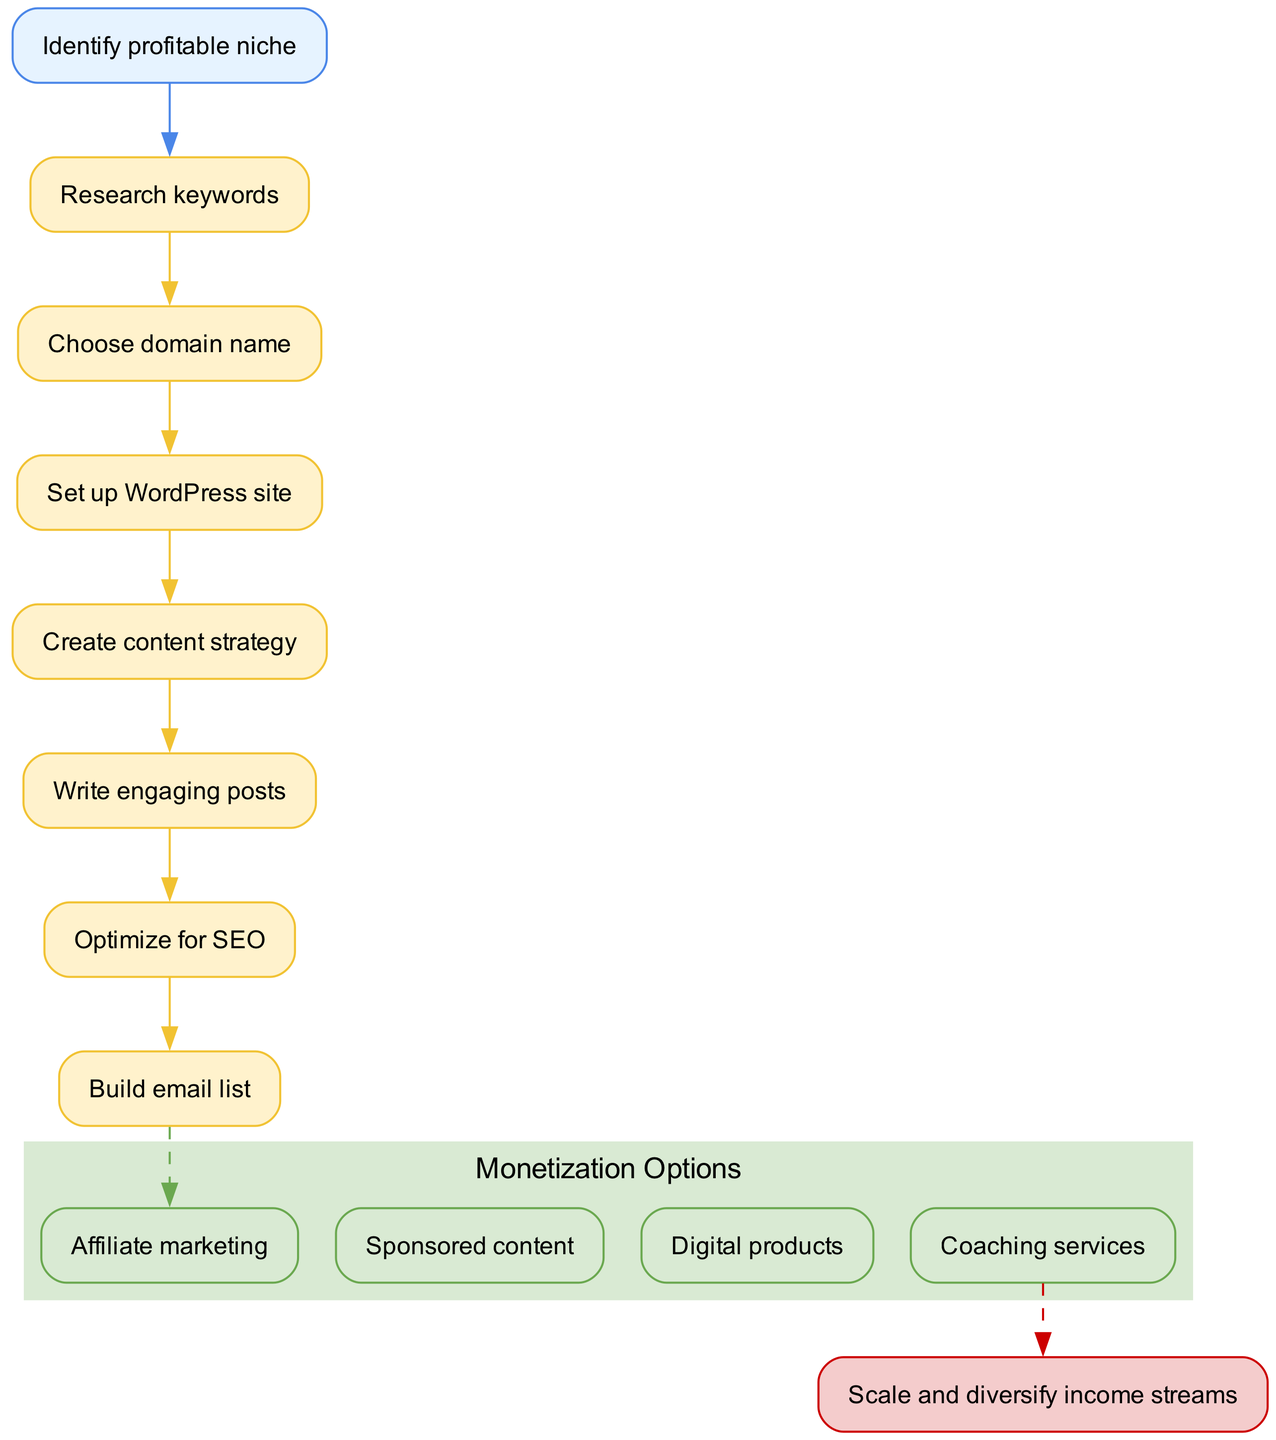What is the first step in creating a niche blog? The flowchart starts with the node labeled "Identify profitable niche," which is clearly the first step in the process of creating a niche blog.
Answer: Identify profitable niche How many steps are there before monetization? The diagram outlines a total of 7 steps, from "Research keywords" to "Build email list," all of which lead up to the monetization options.
Answer: 7 What is the final outcome after monetization? According to the flowchart, the end result after the monetization options is to "Scale and diversify income streams," which is clearly indicated as the final outcome.
Answer: Scale and diversify income streams Which step precedes "Optimize for SEO"? In the diagram, "Write engaging posts" is shown to directly connect to "Optimize for SEO," making it the step that directly precedes it.
Answer: Write engaging posts How many monetization options are available? The flowchart lists four distinct monetization options: "Affiliate marketing," "Sponsored content," "Digital products," and "Coaching services." By counting them in the diagram, we see that there are four options total.
Answer: 4 What label is given to the cluster of monetization options? The cluster of monetization options is labeled "Monetization Options" in the diagram, making it straightforward to identify the grouping of these nodes.
Answer: Monetization Options Which step is connected to "Build email list" as its predecessor? The diagram indicates that the step "Optimize for SEO" is connected to "Build email list," meaning that "Optimize for SEO" is the direct predecessor to this step.
Answer: Optimize for SEO What type of relationship is shown between "Write engaging posts" and "Optimize for SEO"? The relationship shown in the diagram between these two steps is a directed edge, indicating a linear flow from "Write engaging posts" to "Optimize for SEO" as part of the process steps.
Answer: Directed edge Which node has a dashed line connecting to it? The node "end" is connected to "monetize_3" with a dashed line, signifying that it is the pathway that leads to the conclusion of the flow.
Answer: end 